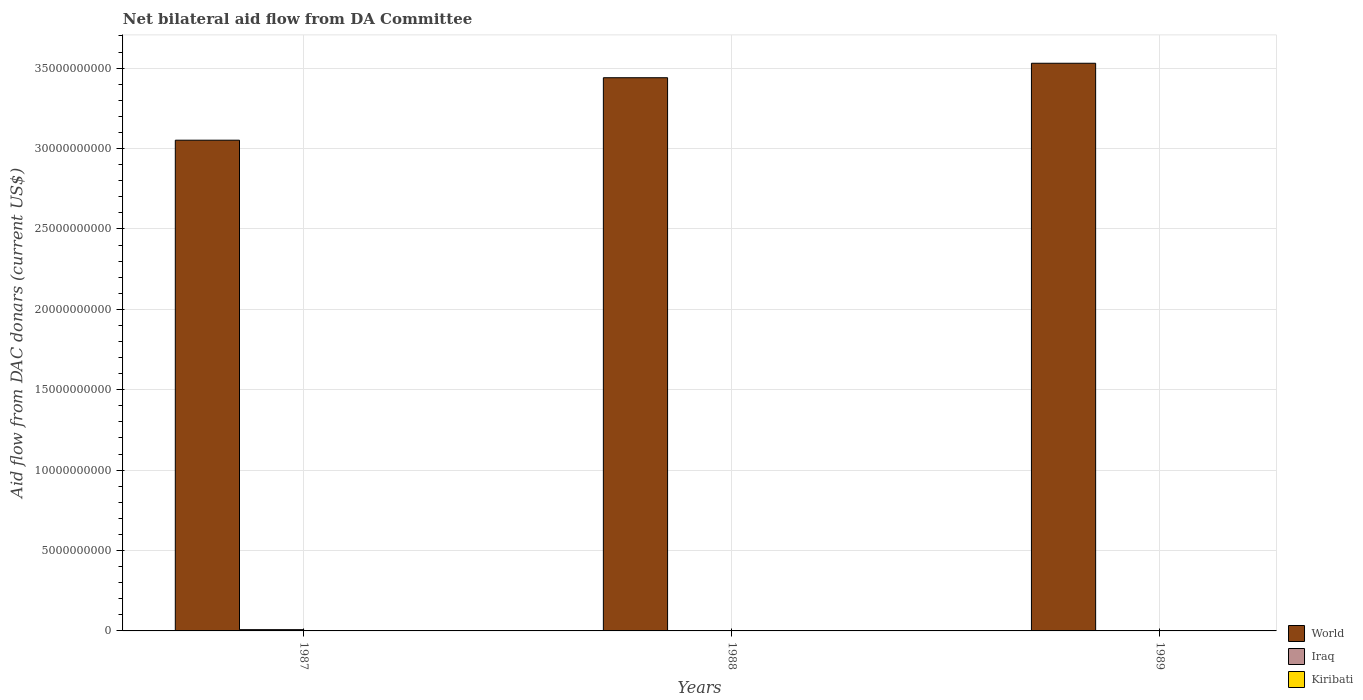Are the number of bars per tick equal to the number of legend labels?
Make the answer very short. No. Are the number of bars on each tick of the X-axis equal?
Provide a succinct answer. No. How many bars are there on the 3rd tick from the right?
Provide a succinct answer. 3. In how many cases, is the number of bars for a given year not equal to the number of legend labels?
Your answer should be compact. 2. Across all years, what is the maximum aid flow in in World?
Your answer should be very brief. 3.53e+1. Across all years, what is the minimum aid flow in in Iraq?
Give a very brief answer. 0. In which year was the aid flow in in World maximum?
Offer a terse response. 1989. What is the total aid flow in in Kiribati in the graph?
Give a very brief answer. 4.74e+07. What is the difference between the aid flow in in Kiribati in 1988 and that in 1989?
Provide a succinct answer. -7.40e+05. What is the difference between the aid flow in in World in 1988 and the aid flow in in Iraq in 1987?
Give a very brief answer. 3.43e+1. What is the average aid flow in in Iraq per year?
Ensure brevity in your answer.  2.64e+07. In the year 1988, what is the difference between the aid flow in in Kiribati and aid flow in in World?
Your answer should be very brief. -3.44e+1. In how many years, is the aid flow in in Kiribati greater than 26000000000 US$?
Offer a terse response. 0. What is the ratio of the aid flow in in World in 1987 to that in 1988?
Provide a short and direct response. 0.89. Is the difference between the aid flow in in Kiribati in 1987 and 1988 greater than the difference between the aid flow in in World in 1987 and 1988?
Keep it short and to the point. Yes. What is the difference between the highest and the second highest aid flow in in Kiribati?
Your answer should be compact. 9.30e+05. What is the difference between the highest and the lowest aid flow in in Iraq?
Offer a very short reply. 7.93e+07. In how many years, is the aid flow in in Kiribati greater than the average aid flow in in Kiribati taken over all years?
Provide a short and direct response. 1. How many bars are there?
Your answer should be compact. 7. How many years are there in the graph?
Keep it short and to the point. 3. Are the values on the major ticks of Y-axis written in scientific E-notation?
Provide a short and direct response. No. Does the graph contain any zero values?
Offer a very short reply. Yes. How many legend labels are there?
Your answer should be very brief. 3. What is the title of the graph?
Make the answer very short. Net bilateral aid flow from DA Committee. What is the label or title of the X-axis?
Make the answer very short. Years. What is the label or title of the Y-axis?
Your answer should be very brief. Aid flow from DAC donars (current US$). What is the Aid flow from DAC donars (current US$) of World in 1987?
Your answer should be very brief. 3.05e+1. What is the Aid flow from DAC donars (current US$) in Iraq in 1987?
Give a very brief answer. 7.93e+07. What is the Aid flow from DAC donars (current US$) in Kiribati in 1987?
Ensure brevity in your answer.  1.66e+07. What is the Aid flow from DAC donars (current US$) in World in 1988?
Offer a very short reply. 3.44e+1. What is the Aid flow from DAC donars (current US$) of Iraq in 1988?
Ensure brevity in your answer.  0. What is the Aid flow from DAC donars (current US$) of Kiribati in 1988?
Ensure brevity in your answer.  1.50e+07. What is the Aid flow from DAC donars (current US$) of World in 1989?
Offer a terse response. 3.53e+1. What is the Aid flow from DAC donars (current US$) of Kiribati in 1989?
Offer a terse response. 1.57e+07. Across all years, what is the maximum Aid flow from DAC donars (current US$) of World?
Offer a terse response. 3.53e+1. Across all years, what is the maximum Aid flow from DAC donars (current US$) in Iraq?
Ensure brevity in your answer.  7.93e+07. Across all years, what is the maximum Aid flow from DAC donars (current US$) of Kiribati?
Your response must be concise. 1.66e+07. Across all years, what is the minimum Aid flow from DAC donars (current US$) of World?
Ensure brevity in your answer.  3.05e+1. Across all years, what is the minimum Aid flow from DAC donars (current US$) in Kiribati?
Your answer should be very brief. 1.50e+07. What is the total Aid flow from DAC donars (current US$) of World in the graph?
Provide a short and direct response. 1.00e+11. What is the total Aid flow from DAC donars (current US$) in Iraq in the graph?
Give a very brief answer. 7.93e+07. What is the total Aid flow from DAC donars (current US$) of Kiribati in the graph?
Ensure brevity in your answer.  4.74e+07. What is the difference between the Aid flow from DAC donars (current US$) of World in 1987 and that in 1988?
Offer a very short reply. -3.89e+09. What is the difference between the Aid flow from DAC donars (current US$) in Kiribati in 1987 and that in 1988?
Ensure brevity in your answer.  1.67e+06. What is the difference between the Aid flow from DAC donars (current US$) in World in 1987 and that in 1989?
Keep it short and to the point. -4.79e+09. What is the difference between the Aid flow from DAC donars (current US$) of Kiribati in 1987 and that in 1989?
Your answer should be compact. 9.30e+05. What is the difference between the Aid flow from DAC donars (current US$) in World in 1988 and that in 1989?
Give a very brief answer. -9.00e+08. What is the difference between the Aid flow from DAC donars (current US$) of Kiribati in 1988 and that in 1989?
Provide a short and direct response. -7.40e+05. What is the difference between the Aid flow from DAC donars (current US$) of World in 1987 and the Aid flow from DAC donars (current US$) of Kiribati in 1988?
Offer a very short reply. 3.05e+1. What is the difference between the Aid flow from DAC donars (current US$) in Iraq in 1987 and the Aid flow from DAC donars (current US$) in Kiribati in 1988?
Make the answer very short. 6.44e+07. What is the difference between the Aid flow from DAC donars (current US$) of World in 1987 and the Aid flow from DAC donars (current US$) of Kiribati in 1989?
Your response must be concise. 3.05e+1. What is the difference between the Aid flow from DAC donars (current US$) in Iraq in 1987 and the Aid flow from DAC donars (current US$) in Kiribati in 1989?
Offer a terse response. 6.36e+07. What is the difference between the Aid flow from DAC donars (current US$) in World in 1988 and the Aid flow from DAC donars (current US$) in Kiribati in 1989?
Give a very brief answer. 3.44e+1. What is the average Aid flow from DAC donars (current US$) of World per year?
Your answer should be compact. 3.34e+1. What is the average Aid flow from DAC donars (current US$) in Iraq per year?
Provide a short and direct response. 2.64e+07. What is the average Aid flow from DAC donars (current US$) of Kiribati per year?
Your answer should be very brief. 1.58e+07. In the year 1987, what is the difference between the Aid flow from DAC donars (current US$) in World and Aid flow from DAC donars (current US$) in Iraq?
Ensure brevity in your answer.  3.04e+1. In the year 1987, what is the difference between the Aid flow from DAC donars (current US$) in World and Aid flow from DAC donars (current US$) in Kiribati?
Your response must be concise. 3.05e+1. In the year 1987, what is the difference between the Aid flow from DAC donars (current US$) of Iraq and Aid flow from DAC donars (current US$) of Kiribati?
Make the answer very short. 6.27e+07. In the year 1988, what is the difference between the Aid flow from DAC donars (current US$) of World and Aid flow from DAC donars (current US$) of Kiribati?
Your answer should be compact. 3.44e+1. In the year 1989, what is the difference between the Aid flow from DAC donars (current US$) in World and Aid flow from DAC donars (current US$) in Kiribati?
Offer a very short reply. 3.53e+1. What is the ratio of the Aid flow from DAC donars (current US$) in World in 1987 to that in 1988?
Your answer should be very brief. 0.89. What is the ratio of the Aid flow from DAC donars (current US$) in Kiribati in 1987 to that in 1988?
Keep it short and to the point. 1.11. What is the ratio of the Aid flow from DAC donars (current US$) of World in 1987 to that in 1989?
Ensure brevity in your answer.  0.86. What is the ratio of the Aid flow from DAC donars (current US$) in Kiribati in 1987 to that in 1989?
Ensure brevity in your answer.  1.06. What is the ratio of the Aid flow from DAC donars (current US$) in World in 1988 to that in 1989?
Keep it short and to the point. 0.97. What is the ratio of the Aid flow from DAC donars (current US$) in Kiribati in 1988 to that in 1989?
Your response must be concise. 0.95. What is the difference between the highest and the second highest Aid flow from DAC donars (current US$) of World?
Give a very brief answer. 9.00e+08. What is the difference between the highest and the second highest Aid flow from DAC donars (current US$) in Kiribati?
Your answer should be compact. 9.30e+05. What is the difference between the highest and the lowest Aid flow from DAC donars (current US$) in World?
Your answer should be compact. 4.79e+09. What is the difference between the highest and the lowest Aid flow from DAC donars (current US$) of Iraq?
Your answer should be compact. 7.93e+07. What is the difference between the highest and the lowest Aid flow from DAC donars (current US$) in Kiribati?
Your answer should be very brief. 1.67e+06. 